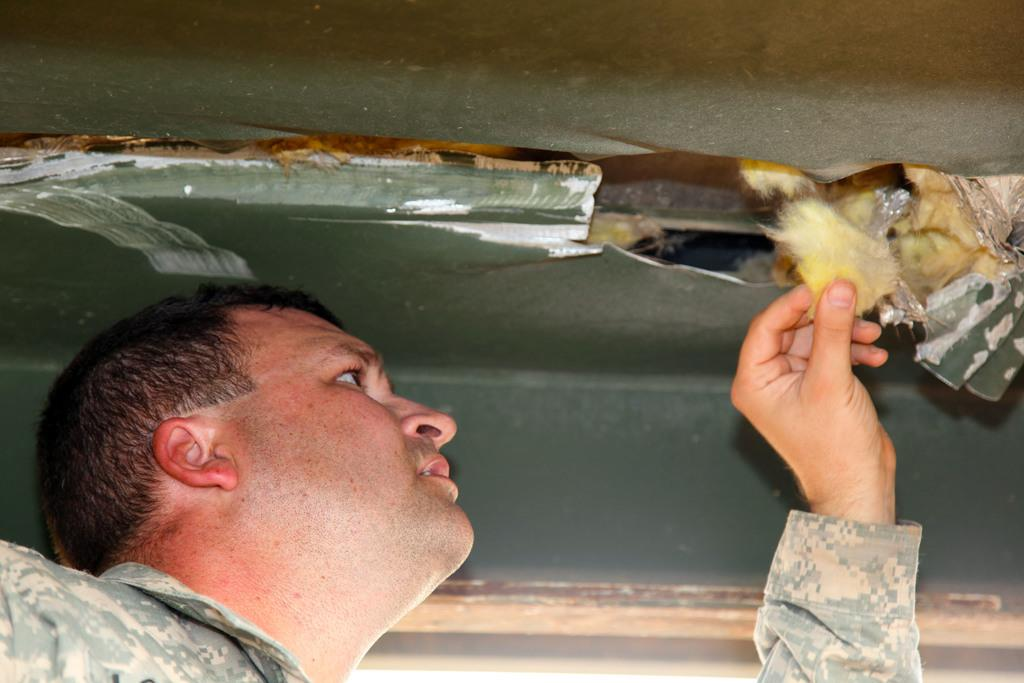What is the main subject of the image? The main subject of the image is a man. What is the man holding in his hand? Unfortunately, the specific object the man is holding cannot be determined from the provided facts. What direction is the caption pointing in the image? There is no caption present in the image, so it is not possible to determine the direction it might be pointing. 